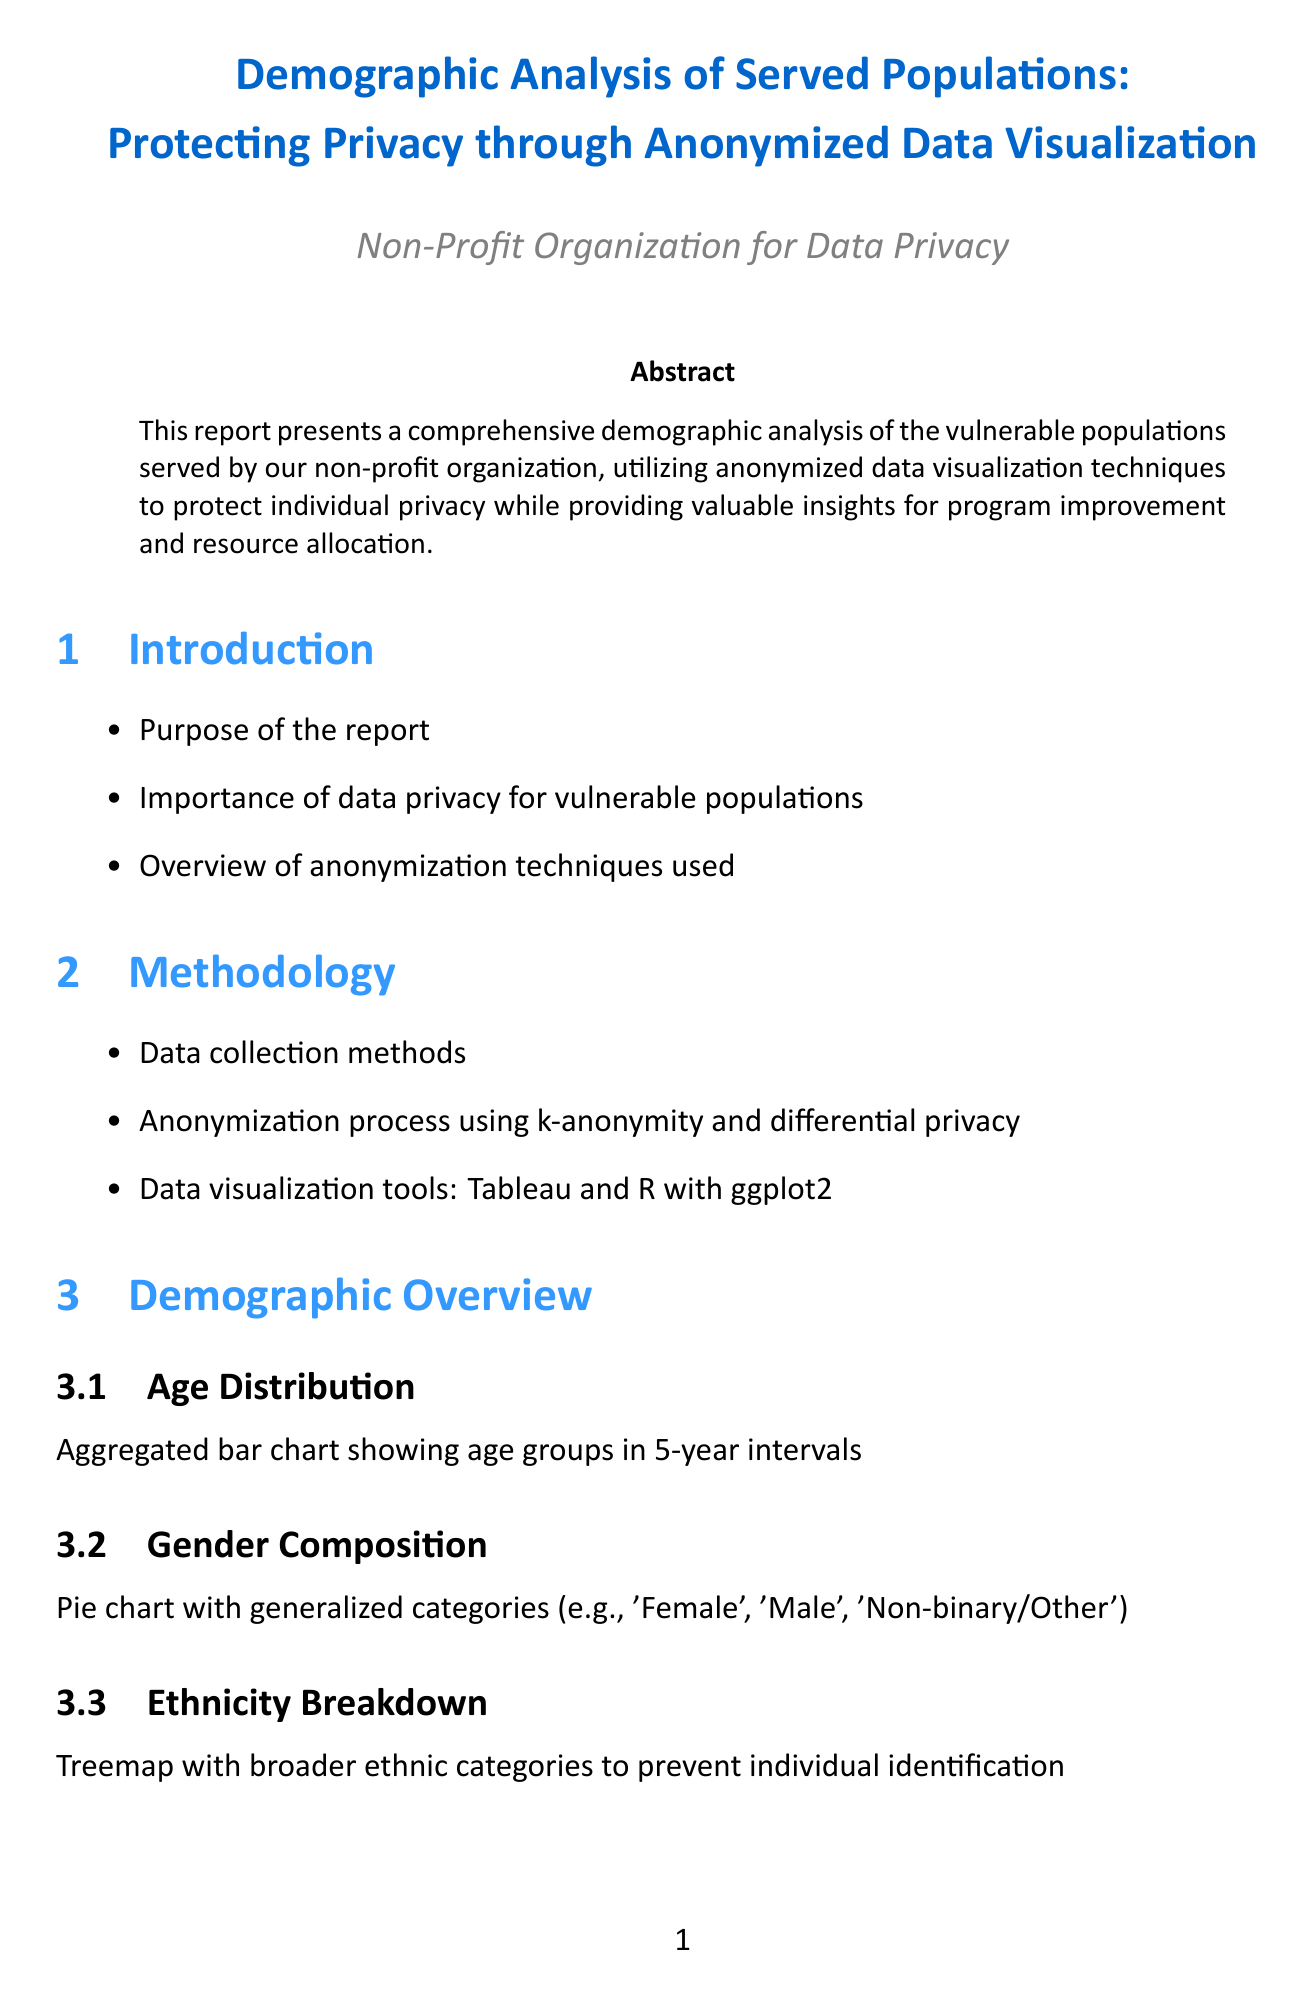What is the title of the report? The title is stated at the beginning of the document.
Answer: Demographic Analysis of Served Populations: Protecting Privacy through Anonymized Data Visualization What visualization technique is used for Age Distribution? This is listed under the Demographic Overview section and mentions the specific type of chart used.
Answer: Aggregated bar chart What software tool is used for geospatial analysis? The software tools are listed towards the end of the document, specifying the tools used for various analyses.
Answer: QGIS What is the purpose of data anonymization techniques mentioned in the report? The importance of these techniques is discussed in the Introduction section.
Answer: Protect individual privacy Which category shows employment status visualization? This is part of the Socioeconomic Indicators section, specifically outlining the type of chart used.
Answer: Grouped bar chart What percentage of the demographic report focuses on geographic distribution? This is a reasoning question, balancing multiple sections to interpret the emphasis on geographic data.
Answer: Not directly quantifiable based on the document content What statistical method is mentioned for anonymization? This is specified in the Methodology section regarding data protection methods used.
Answer: k-anonymity What is the overarching theme of the 'Conclusion and Next Steps' section? The conclusion summarizes insights and proposed actions based on the findings throughout the report.
Answer: Summary of key findings What type of chart is used to show income levels without outliers? This is listed under the Socioeconomic Indicators section and specifies the visual representation used.
Answer: Box plot 